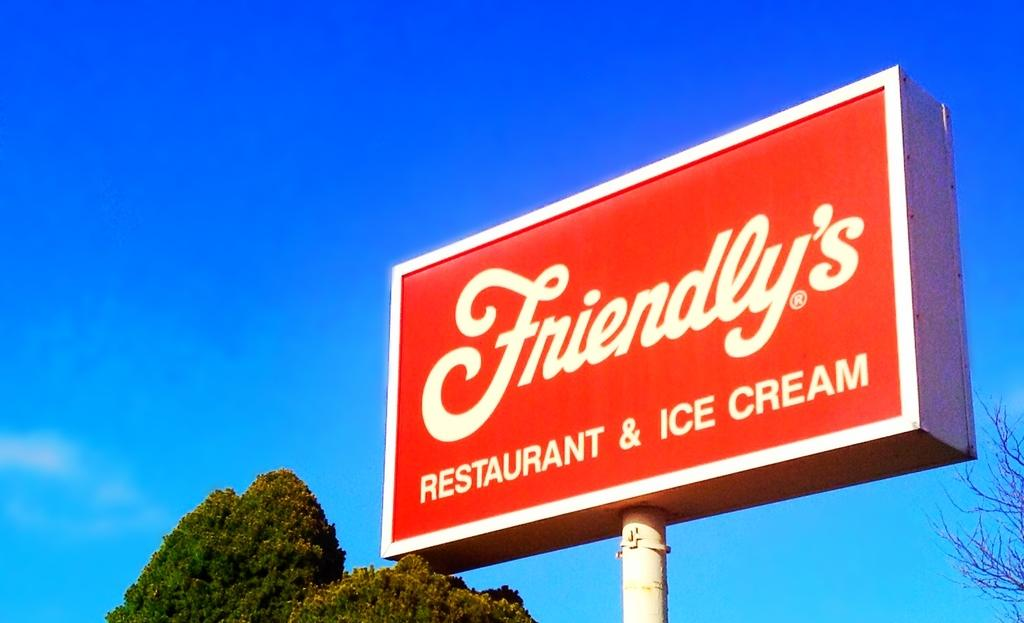Provide a one-sentence caption for the provided image. The sign is from Friendly's RESTAURANT AND ICE CREAM place. 